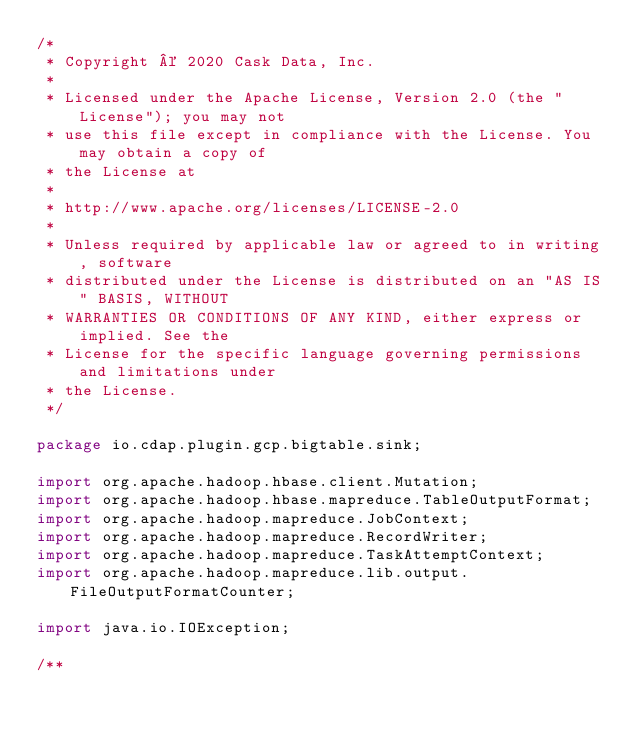<code> <loc_0><loc_0><loc_500><loc_500><_Java_>/*
 * Copyright © 2020 Cask Data, Inc.
 *
 * Licensed under the Apache License, Version 2.0 (the "License"); you may not
 * use this file except in compliance with the License. You may obtain a copy of
 * the License at
 *
 * http://www.apache.org/licenses/LICENSE-2.0
 *
 * Unless required by applicable law or agreed to in writing, software
 * distributed under the License is distributed on an "AS IS" BASIS, WITHOUT
 * WARRANTIES OR CONDITIONS OF ANY KIND, either express or implied. See the
 * License for the specific language governing permissions and limitations under
 * the License.
 */

package io.cdap.plugin.gcp.bigtable.sink;

import org.apache.hadoop.hbase.client.Mutation;
import org.apache.hadoop.hbase.mapreduce.TableOutputFormat;
import org.apache.hadoop.mapreduce.JobContext;
import org.apache.hadoop.mapreduce.RecordWriter;
import org.apache.hadoop.mapreduce.TaskAttemptContext;
import org.apache.hadoop.mapreduce.lib.output.FileOutputFormatCounter;

import java.io.IOException;

/**</code> 